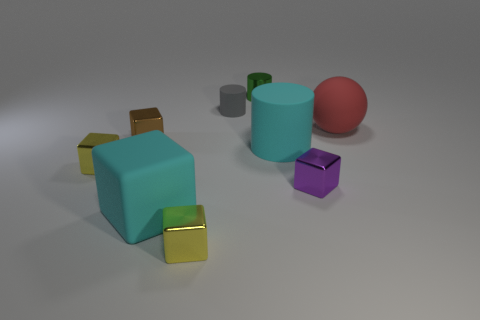How many small objects are to the left of the green cylinder?
Your answer should be compact. 4. Are there any other things that have the same material as the tiny purple object?
Your answer should be compact. Yes. Does the big cyan matte object that is right of the big cube have the same shape as the red thing?
Give a very brief answer. No. There is a matte thing that is behind the rubber sphere; what color is it?
Your response must be concise. Gray. There is a purple thing that is made of the same material as the green object; what is its shape?
Your answer should be very brief. Cube. Is there anything else of the same color as the big rubber cylinder?
Your answer should be compact. Yes. Is the number of large red rubber objects that are left of the metal cylinder greater than the number of yellow objects in front of the large cube?
Your answer should be compact. No. What number of purple blocks are the same size as the metallic cylinder?
Offer a terse response. 1. Is the number of large cyan things that are on the left side of the cyan matte cube less than the number of big cyan objects that are to the right of the small gray matte cylinder?
Offer a terse response. Yes. Are there any cyan matte objects of the same shape as the small brown metallic object?
Your answer should be compact. Yes. 